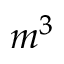<formula> <loc_0><loc_0><loc_500><loc_500>m ^ { 3 }</formula> 